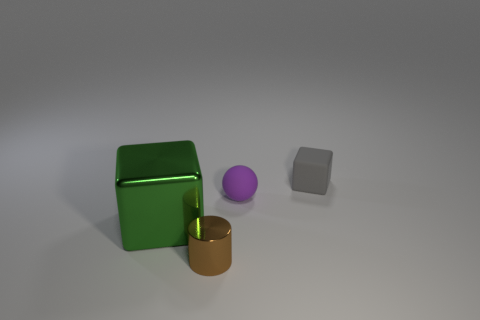What materials do the objects in the image seem to be made of? The objects in the image seem to have different textures suggesting different materials. The green object has a shiny, reflective surface that could resemble polished metal or plastic, the purple sphere looks matte, indicating a possible rubber or plastic material, and the gold cylinder has a reflective surface similar to polished metal. The grey cube appears to have a matte finish, which might imply a metallic or stone-like material. 